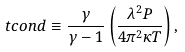<formula> <loc_0><loc_0><loc_500><loc_500>\ t c o n d \equiv \frac { \gamma } { \gamma - 1 } \left ( \frac { \lambda ^ { 2 } P } { 4 \pi ^ { 2 } \kappa T } \right ) ,</formula> 